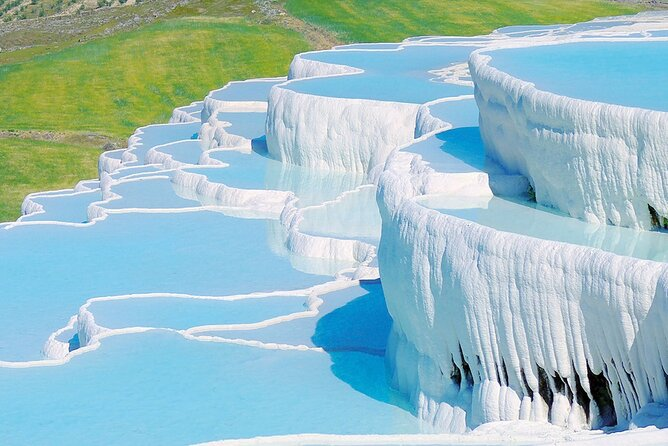How do the travertine terraces of Pamukkale form, and what makes the water appear so brightly colored? The travertine terraces of Pamukkale are formed by calcium carbonate mineral deposits from the flowing thermal springs. The brilliantly blue appearance of the water is due to its high mineral content, particularly calcium, which reflects the sunlight, creating that vivid blue hue. Over thousands of years, these mineral-rich waters have cascaded over the landscape, depositing layers of travertine and creating natural terraces. 